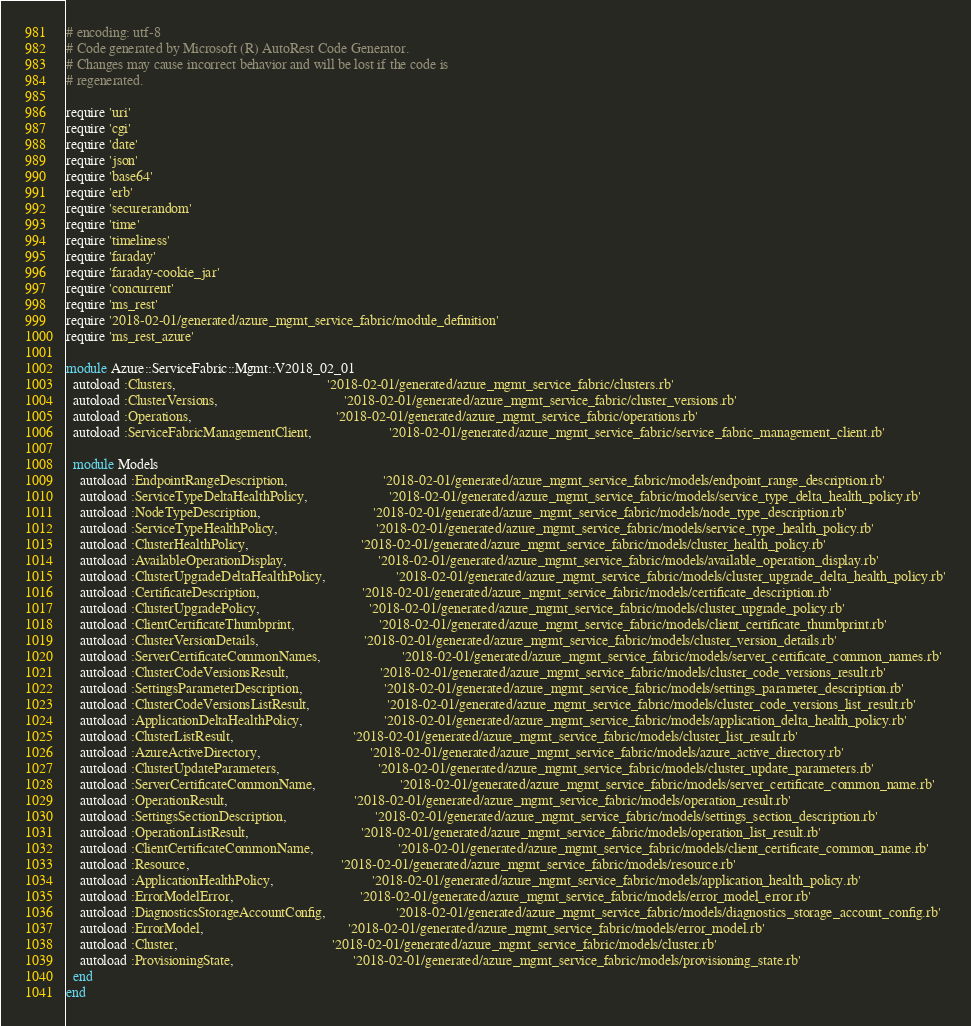<code> <loc_0><loc_0><loc_500><loc_500><_Ruby_># encoding: utf-8
# Code generated by Microsoft (R) AutoRest Code Generator.
# Changes may cause incorrect behavior and will be lost if the code is
# regenerated.

require 'uri'
require 'cgi'
require 'date'
require 'json'
require 'base64'
require 'erb'
require 'securerandom'
require 'time'
require 'timeliness'
require 'faraday'
require 'faraday-cookie_jar'
require 'concurrent'
require 'ms_rest'
require '2018-02-01/generated/azure_mgmt_service_fabric/module_definition'
require 'ms_rest_azure'

module Azure::ServiceFabric::Mgmt::V2018_02_01
  autoload :Clusters,                                           '2018-02-01/generated/azure_mgmt_service_fabric/clusters.rb'
  autoload :ClusterVersions,                                    '2018-02-01/generated/azure_mgmt_service_fabric/cluster_versions.rb'
  autoload :Operations,                                         '2018-02-01/generated/azure_mgmt_service_fabric/operations.rb'
  autoload :ServiceFabricManagementClient,                      '2018-02-01/generated/azure_mgmt_service_fabric/service_fabric_management_client.rb'

  module Models
    autoload :EndpointRangeDescription,                           '2018-02-01/generated/azure_mgmt_service_fabric/models/endpoint_range_description.rb'
    autoload :ServiceTypeDeltaHealthPolicy,                       '2018-02-01/generated/azure_mgmt_service_fabric/models/service_type_delta_health_policy.rb'
    autoload :NodeTypeDescription,                                '2018-02-01/generated/azure_mgmt_service_fabric/models/node_type_description.rb'
    autoload :ServiceTypeHealthPolicy,                            '2018-02-01/generated/azure_mgmt_service_fabric/models/service_type_health_policy.rb'
    autoload :ClusterHealthPolicy,                                '2018-02-01/generated/azure_mgmt_service_fabric/models/cluster_health_policy.rb'
    autoload :AvailableOperationDisplay,                          '2018-02-01/generated/azure_mgmt_service_fabric/models/available_operation_display.rb'
    autoload :ClusterUpgradeDeltaHealthPolicy,                    '2018-02-01/generated/azure_mgmt_service_fabric/models/cluster_upgrade_delta_health_policy.rb'
    autoload :CertificateDescription,                             '2018-02-01/generated/azure_mgmt_service_fabric/models/certificate_description.rb'
    autoload :ClusterUpgradePolicy,                               '2018-02-01/generated/azure_mgmt_service_fabric/models/cluster_upgrade_policy.rb'
    autoload :ClientCertificateThumbprint,                        '2018-02-01/generated/azure_mgmt_service_fabric/models/client_certificate_thumbprint.rb'
    autoload :ClusterVersionDetails,                              '2018-02-01/generated/azure_mgmt_service_fabric/models/cluster_version_details.rb'
    autoload :ServerCertificateCommonNames,                       '2018-02-01/generated/azure_mgmt_service_fabric/models/server_certificate_common_names.rb'
    autoload :ClusterCodeVersionsResult,                          '2018-02-01/generated/azure_mgmt_service_fabric/models/cluster_code_versions_result.rb'
    autoload :SettingsParameterDescription,                       '2018-02-01/generated/azure_mgmt_service_fabric/models/settings_parameter_description.rb'
    autoload :ClusterCodeVersionsListResult,                      '2018-02-01/generated/azure_mgmt_service_fabric/models/cluster_code_versions_list_result.rb'
    autoload :ApplicationDeltaHealthPolicy,                       '2018-02-01/generated/azure_mgmt_service_fabric/models/application_delta_health_policy.rb'
    autoload :ClusterListResult,                                  '2018-02-01/generated/azure_mgmt_service_fabric/models/cluster_list_result.rb'
    autoload :AzureActiveDirectory,                               '2018-02-01/generated/azure_mgmt_service_fabric/models/azure_active_directory.rb'
    autoload :ClusterUpdateParameters,                            '2018-02-01/generated/azure_mgmt_service_fabric/models/cluster_update_parameters.rb'
    autoload :ServerCertificateCommonName,                        '2018-02-01/generated/azure_mgmt_service_fabric/models/server_certificate_common_name.rb'
    autoload :OperationResult,                                    '2018-02-01/generated/azure_mgmt_service_fabric/models/operation_result.rb'
    autoload :SettingsSectionDescription,                         '2018-02-01/generated/azure_mgmt_service_fabric/models/settings_section_description.rb'
    autoload :OperationListResult,                                '2018-02-01/generated/azure_mgmt_service_fabric/models/operation_list_result.rb'
    autoload :ClientCertificateCommonName,                        '2018-02-01/generated/azure_mgmt_service_fabric/models/client_certificate_common_name.rb'
    autoload :Resource,                                           '2018-02-01/generated/azure_mgmt_service_fabric/models/resource.rb'
    autoload :ApplicationHealthPolicy,                            '2018-02-01/generated/azure_mgmt_service_fabric/models/application_health_policy.rb'
    autoload :ErrorModelError,                                    '2018-02-01/generated/azure_mgmt_service_fabric/models/error_model_error.rb'
    autoload :DiagnosticsStorageAccountConfig,                    '2018-02-01/generated/azure_mgmt_service_fabric/models/diagnostics_storage_account_config.rb'
    autoload :ErrorModel,                                         '2018-02-01/generated/azure_mgmt_service_fabric/models/error_model.rb'
    autoload :Cluster,                                            '2018-02-01/generated/azure_mgmt_service_fabric/models/cluster.rb'
    autoload :ProvisioningState,                                  '2018-02-01/generated/azure_mgmt_service_fabric/models/provisioning_state.rb'
  end
end
</code> 